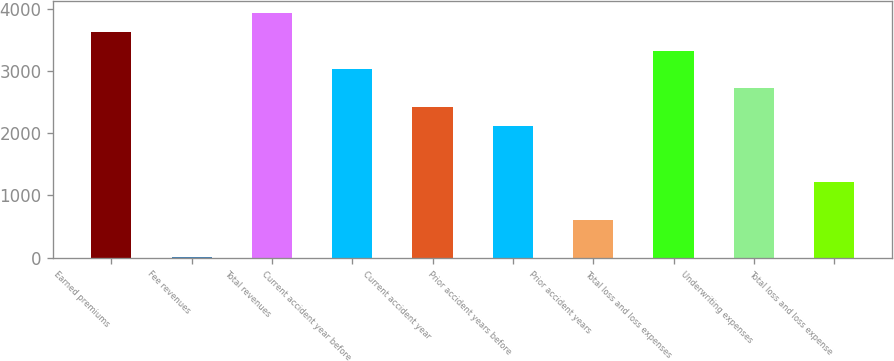<chart> <loc_0><loc_0><loc_500><loc_500><bar_chart><fcel>Earned premiums<fcel>Fee revenues<fcel>Total revenues<fcel>Current accident year before<fcel>Current accident year<fcel>Prior accident years before<fcel>Prior accident years<fcel>Total loss and loss expenses<fcel>Underwriting expenses<fcel>Total loss and loss expense<nl><fcel>3638.8<fcel>4<fcel>3941.7<fcel>3033<fcel>2427.2<fcel>2124.3<fcel>609.8<fcel>3335.9<fcel>2730.1<fcel>1215.6<nl></chart> 